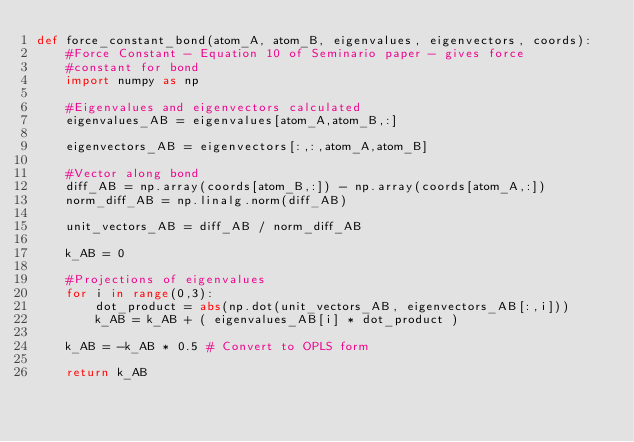Convert code to text. <code><loc_0><loc_0><loc_500><loc_500><_Python_>def force_constant_bond(atom_A, atom_B, eigenvalues, eigenvectors, coords):
    #Force Constant - Equation 10 of Seminario paper - gives force
    #constant for bond
    import numpy as np

    #Eigenvalues and eigenvectors calculated 
    eigenvalues_AB = eigenvalues[atom_A,atom_B,:]

    eigenvectors_AB = eigenvectors[:,:,atom_A,atom_B]

    #Vector along bond 
    diff_AB = np.array(coords[atom_B,:]) - np.array(coords[atom_A,:])
    norm_diff_AB = np.linalg.norm(diff_AB)

    unit_vectors_AB = diff_AB / norm_diff_AB
    
    k_AB = 0 

    #Projections of eigenvalues 
    for i in range(0,3):
        dot_product = abs(np.dot(unit_vectors_AB, eigenvectors_AB[:,i]))
        k_AB = k_AB + ( eigenvalues_AB[i] * dot_product )

    k_AB = -k_AB * 0.5 # Convert to OPLS form

    return k_AB






        
</code> 